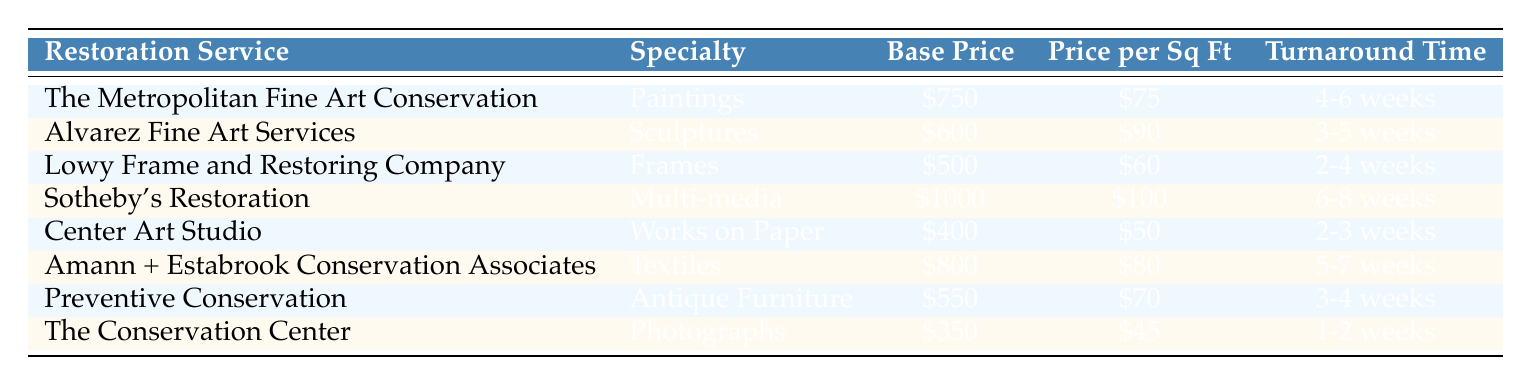What is the base price for The Conservation Center? The base price for The Conservation Center is found directly in the table under the "Base Price" column for that specific service, which is listed as $350.
Answer: $350 Which restoration service has the highest price per square foot? To find the restoration service with the highest price per square foot, we compare the "Price per Square Foot" values across all services. Sotheby's Restoration has the highest at $100.
Answer: Sotheby's Restoration Is the turnaround time for Alvarez Fine Art Services longer than that for Center Art Studio? Alvarez Fine Art Services has a turnaround time of 3-5 weeks, while Center Art Studio has a turnaround time of 2-3 weeks. Since 3-5 weeks is longer, the answer is yes.
Answer: Yes What is the average base price of the restoration services? To find the average, we first sum the base prices of all services: $750 + $600 + $500 + $1000 + $400 + $800 + $550 + $350 = $3950. There are 8 services, so the average is $3950 / 8 = $493.75.
Answer: $493.75 Is the price for restoring photographs cheaper than the price for restoring frames? The price for restoring photographs at The Conservation Center is $350, while the price for frames at Lowy Frame and Restoring Company is $500. Since $350 is less than $500, the answer is yes.
Answer: Yes What is the difference in turnaround time between the service with the longest and the shortest turnaround time? Sotheby's Restoration has the longest turnaround time at 6-8 weeks, and The Conservation Center has the shortest at 1-2 weeks. The shortest turnaround time (2 weeks) is subtracted from the longest (8 weeks) resulting in a difference of 6 weeks.
Answer: 6 weeks Which specialty has the lowest base price? By examining the "Base Price" column across all specialties, Center Art Studio for Works on Paper has the lowest at $400, which is the lowest listed value.
Answer: Works on Paper How many services have a price per square foot of $80 or higher? We check the "Price per Square Foot" column for services that are $80 or more. The qualifying services are: Sotheby's Restoration ($100), Alvarez Fine Art Services ($90), and Amann + Estabrook Conservation Associates ($80). This gives us a total of 3 services.
Answer: 3 